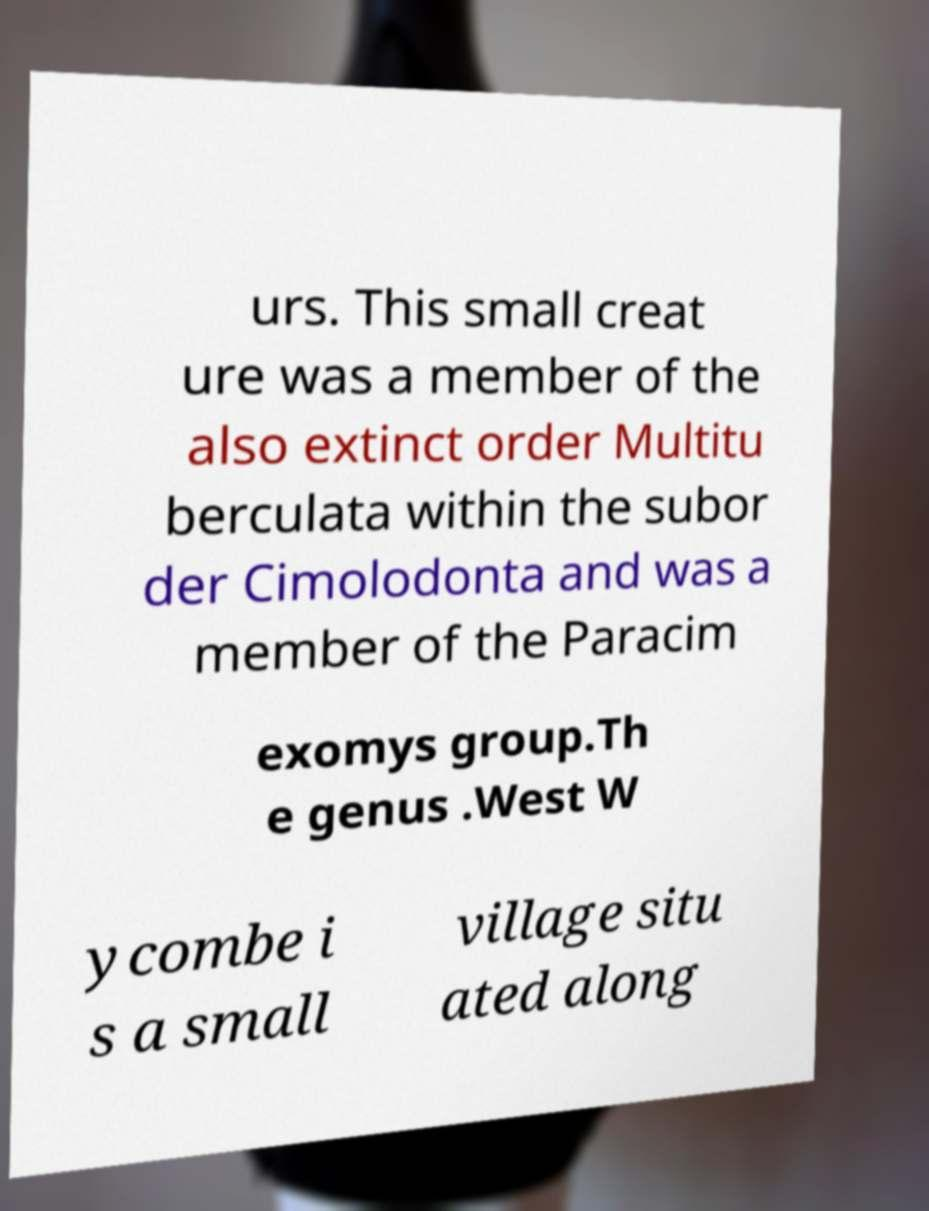Can you read and provide the text displayed in the image?This photo seems to have some interesting text. Can you extract and type it out for me? urs. This small creat ure was a member of the also extinct order Multitu berculata within the subor der Cimolodonta and was a member of the Paracim exomys group.Th e genus .West W ycombe i s a small village situ ated along 